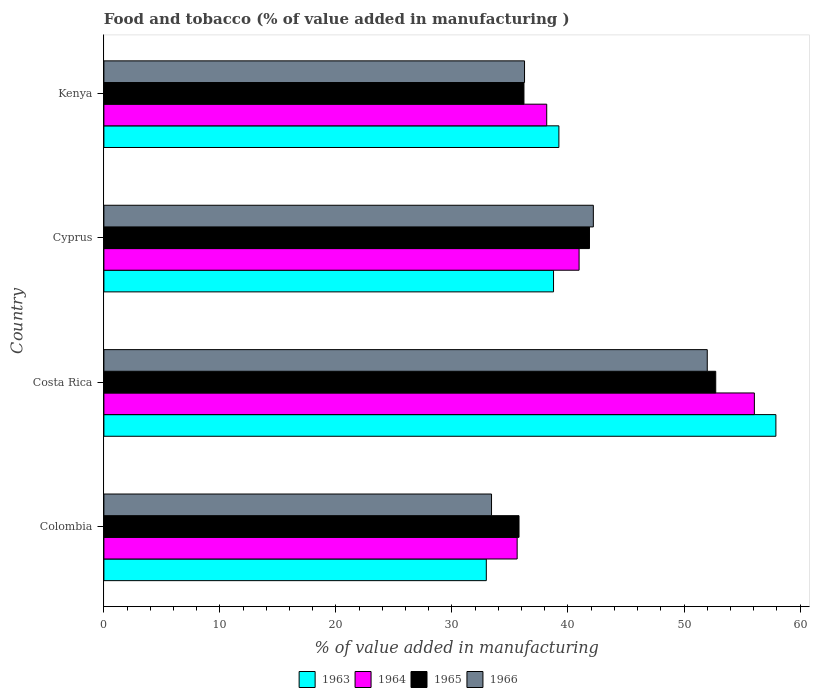How many groups of bars are there?
Your answer should be compact. 4. Are the number of bars per tick equal to the number of legend labels?
Ensure brevity in your answer.  Yes. How many bars are there on the 3rd tick from the top?
Offer a very short reply. 4. How many bars are there on the 3rd tick from the bottom?
Your response must be concise. 4. What is the label of the 4th group of bars from the top?
Your answer should be compact. Colombia. In how many cases, is the number of bars for a given country not equal to the number of legend labels?
Provide a succinct answer. 0. What is the value added in manufacturing food and tobacco in 1964 in Costa Rica?
Provide a short and direct response. 56.07. Across all countries, what is the maximum value added in manufacturing food and tobacco in 1966?
Offer a very short reply. 52. Across all countries, what is the minimum value added in manufacturing food and tobacco in 1966?
Ensure brevity in your answer.  33.41. What is the total value added in manufacturing food and tobacco in 1964 in the graph?
Offer a terse response. 170.81. What is the difference between the value added in manufacturing food and tobacco in 1966 in Costa Rica and that in Kenya?
Make the answer very short. 15.75. What is the difference between the value added in manufacturing food and tobacco in 1963 in Cyprus and the value added in manufacturing food and tobacco in 1964 in Costa Rica?
Offer a very short reply. -17.31. What is the average value added in manufacturing food and tobacco in 1965 per country?
Your answer should be compact. 41.64. What is the difference between the value added in manufacturing food and tobacco in 1965 and value added in manufacturing food and tobacco in 1963 in Cyprus?
Your answer should be very brief. 3.1. What is the ratio of the value added in manufacturing food and tobacco in 1966 in Colombia to that in Costa Rica?
Give a very brief answer. 0.64. Is the difference between the value added in manufacturing food and tobacco in 1965 in Costa Rica and Kenya greater than the difference between the value added in manufacturing food and tobacco in 1963 in Costa Rica and Kenya?
Make the answer very short. No. What is the difference between the highest and the second highest value added in manufacturing food and tobacco in 1965?
Keep it short and to the point. 10.88. What is the difference between the highest and the lowest value added in manufacturing food and tobacco in 1966?
Make the answer very short. 18.59. Is it the case that in every country, the sum of the value added in manufacturing food and tobacco in 1966 and value added in manufacturing food and tobacco in 1963 is greater than the sum of value added in manufacturing food and tobacco in 1965 and value added in manufacturing food and tobacco in 1964?
Your response must be concise. No. What does the 3rd bar from the top in Costa Rica represents?
Give a very brief answer. 1964. What does the 2nd bar from the bottom in Colombia represents?
Your response must be concise. 1964. Is it the case that in every country, the sum of the value added in manufacturing food and tobacco in 1966 and value added in manufacturing food and tobacco in 1965 is greater than the value added in manufacturing food and tobacco in 1964?
Provide a succinct answer. Yes. Are the values on the major ticks of X-axis written in scientific E-notation?
Provide a succinct answer. No. Does the graph contain any zero values?
Your answer should be very brief. No. Where does the legend appear in the graph?
Your answer should be very brief. Bottom center. How many legend labels are there?
Provide a short and direct response. 4. What is the title of the graph?
Offer a very short reply. Food and tobacco (% of value added in manufacturing ). Does "1963" appear as one of the legend labels in the graph?
Your answer should be compact. Yes. What is the label or title of the X-axis?
Provide a succinct answer. % of value added in manufacturing. What is the % of value added in manufacturing of 1963 in Colombia?
Provide a succinct answer. 32.96. What is the % of value added in manufacturing of 1964 in Colombia?
Make the answer very short. 35.62. What is the % of value added in manufacturing of 1965 in Colombia?
Provide a short and direct response. 35.78. What is the % of value added in manufacturing in 1966 in Colombia?
Offer a very short reply. 33.41. What is the % of value added in manufacturing of 1963 in Costa Rica?
Your response must be concise. 57.92. What is the % of value added in manufacturing in 1964 in Costa Rica?
Your answer should be very brief. 56.07. What is the % of value added in manufacturing of 1965 in Costa Rica?
Your answer should be very brief. 52.73. What is the % of value added in manufacturing of 1966 in Costa Rica?
Give a very brief answer. 52. What is the % of value added in manufacturing of 1963 in Cyprus?
Offer a terse response. 38.75. What is the % of value added in manufacturing in 1964 in Cyprus?
Keep it short and to the point. 40.96. What is the % of value added in manufacturing of 1965 in Cyprus?
Your response must be concise. 41.85. What is the % of value added in manufacturing in 1966 in Cyprus?
Ensure brevity in your answer.  42.19. What is the % of value added in manufacturing of 1963 in Kenya?
Ensure brevity in your answer.  39.22. What is the % of value added in manufacturing in 1964 in Kenya?
Offer a very short reply. 38.17. What is the % of value added in manufacturing of 1965 in Kenya?
Offer a terse response. 36.2. What is the % of value added in manufacturing of 1966 in Kenya?
Your answer should be compact. 36.25. Across all countries, what is the maximum % of value added in manufacturing in 1963?
Ensure brevity in your answer.  57.92. Across all countries, what is the maximum % of value added in manufacturing of 1964?
Give a very brief answer. 56.07. Across all countries, what is the maximum % of value added in manufacturing of 1965?
Ensure brevity in your answer.  52.73. Across all countries, what is the maximum % of value added in manufacturing of 1966?
Provide a short and direct response. 52. Across all countries, what is the minimum % of value added in manufacturing of 1963?
Provide a succinct answer. 32.96. Across all countries, what is the minimum % of value added in manufacturing of 1964?
Give a very brief answer. 35.62. Across all countries, what is the minimum % of value added in manufacturing in 1965?
Provide a short and direct response. 35.78. Across all countries, what is the minimum % of value added in manufacturing in 1966?
Your answer should be very brief. 33.41. What is the total % of value added in manufacturing in 1963 in the graph?
Your response must be concise. 168.85. What is the total % of value added in manufacturing in 1964 in the graph?
Ensure brevity in your answer.  170.81. What is the total % of value added in manufacturing of 1965 in the graph?
Your answer should be very brief. 166.57. What is the total % of value added in manufacturing in 1966 in the graph?
Your answer should be very brief. 163.86. What is the difference between the % of value added in manufacturing of 1963 in Colombia and that in Costa Rica?
Offer a very short reply. -24.96. What is the difference between the % of value added in manufacturing in 1964 in Colombia and that in Costa Rica?
Offer a very short reply. -20.45. What is the difference between the % of value added in manufacturing of 1965 in Colombia and that in Costa Rica?
Your answer should be compact. -16.95. What is the difference between the % of value added in manufacturing of 1966 in Colombia and that in Costa Rica?
Your response must be concise. -18.59. What is the difference between the % of value added in manufacturing of 1963 in Colombia and that in Cyprus?
Keep it short and to the point. -5.79. What is the difference between the % of value added in manufacturing in 1964 in Colombia and that in Cyprus?
Provide a succinct answer. -5.34. What is the difference between the % of value added in manufacturing of 1965 in Colombia and that in Cyprus?
Your response must be concise. -6.07. What is the difference between the % of value added in manufacturing in 1966 in Colombia and that in Cyprus?
Your answer should be very brief. -8.78. What is the difference between the % of value added in manufacturing in 1963 in Colombia and that in Kenya?
Keep it short and to the point. -6.26. What is the difference between the % of value added in manufacturing of 1964 in Colombia and that in Kenya?
Provide a succinct answer. -2.55. What is the difference between the % of value added in manufacturing in 1965 in Colombia and that in Kenya?
Your response must be concise. -0.42. What is the difference between the % of value added in manufacturing in 1966 in Colombia and that in Kenya?
Offer a very short reply. -2.84. What is the difference between the % of value added in manufacturing of 1963 in Costa Rica and that in Cyprus?
Offer a terse response. 19.17. What is the difference between the % of value added in manufacturing in 1964 in Costa Rica and that in Cyprus?
Offer a very short reply. 15.11. What is the difference between the % of value added in manufacturing of 1965 in Costa Rica and that in Cyprus?
Offer a terse response. 10.88. What is the difference between the % of value added in manufacturing in 1966 in Costa Rica and that in Cyprus?
Make the answer very short. 9.82. What is the difference between the % of value added in manufacturing in 1963 in Costa Rica and that in Kenya?
Your answer should be very brief. 18.7. What is the difference between the % of value added in manufacturing of 1964 in Costa Rica and that in Kenya?
Offer a terse response. 17.9. What is the difference between the % of value added in manufacturing in 1965 in Costa Rica and that in Kenya?
Offer a terse response. 16.53. What is the difference between the % of value added in manufacturing in 1966 in Costa Rica and that in Kenya?
Your answer should be compact. 15.75. What is the difference between the % of value added in manufacturing of 1963 in Cyprus and that in Kenya?
Your response must be concise. -0.46. What is the difference between the % of value added in manufacturing in 1964 in Cyprus and that in Kenya?
Offer a terse response. 2.79. What is the difference between the % of value added in manufacturing of 1965 in Cyprus and that in Kenya?
Provide a short and direct response. 5.65. What is the difference between the % of value added in manufacturing of 1966 in Cyprus and that in Kenya?
Make the answer very short. 5.93. What is the difference between the % of value added in manufacturing in 1963 in Colombia and the % of value added in manufacturing in 1964 in Costa Rica?
Your answer should be very brief. -23.11. What is the difference between the % of value added in manufacturing in 1963 in Colombia and the % of value added in manufacturing in 1965 in Costa Rica?
Your response must be concise. -19.77. What is the difference between the % of value added in manufacturing of 1963 in Colombia and the % of value added in manufacturing of 1966 in Costa Rica?
Your answer should be very brief. -19.04. What is the difference between the % of value added in manufacturing of 1964 in Colombia and the % of value added in manufacturing of 1965 in Costa Rica?
Ensure brevity in your answer.  -17.11. What is the difference between the % of value added in manufacturing in 1964 in Colombia and the % of value added in manufacturing in 1966 in Costa Rica?
Your answer should be compact. -16.38. What is the difference between the % of value added in manufacturing in 1965 in Colombia and the % of value added in manufacturing in 1966 in Costa Rica?
Ensure brevity in your answer.  -16.22. What is the difference between the % of value added in manufacturing of 1963 in Colombia and the % of value added in manufacturing of 1964 in Cyprus?
Your answer should be very brief. -8. What is the difference between the % of value added in manufacturing in 1963 in Colombia and the % of value added in manufacturing in 1965 in Cyprus?
Offer a very short reply. -8.89. What is the difference between the % of value added in manufacturing of 1963 in Colombia and the % of value added in manufacturing of 1966 in Cyprus?
Your answer should be compact. -9.23. What is the difference between the % of value added in manufacturing of 1964 in Colombia and the % of value added in manufacturing of 1965 in Cyprus?
Your response must be concise. -6.23. What is the difference between the % of value added in manufacturing in 1964 in Colombia and the % of value added in manufacturing in 1966 in Cyprus?
Your response must be concise. -6.57. What is the difference between the % of value added in manufacturing of 1965 in Colombia and the % of value added in manufacturing of 1966 in Cyprus?
Provide a short and direct response. -6.41. What is the difference between the % of value added in manufacturing of 1963 in Colombia and the % of value added in manufacturing of 1964 in Kenya?
Keep it short and to the point. -5.21. What is the difference between the % of value added in manufacturing in 1963 in Colombia and the % of value added in manufacturing in 1965 in Kenya?
Keep it short and to the point. -3.24. What is the difference between the % of value added in manufacturing in 1963 in Colombia and the % of value added in manufacturing in 1966 in Kenya?
Give a very brief answer. -3.29. What is the difference between the % of value added in manufacturing of 1964 in Colombia and the % of value added in manufacturing of 1965 in Kenya?
Give a very brief answer. -0.58. What is the difference between the % of value added in manufacturing in 1964 in Colombia and the % of value added in manufacturing in 1966 in Kenya?
Make the answer very short. -0.63. What is the difference between the % of value added in manufacturing of 1965 in Colombia and the % of value added in manufacturing of 1966 in Kenya?
Provide a short and direct response. -0.47. What is the difference between the % of value added in manufacturing in 1963 in Costa Rica and the % of value added in manufacturing in 1964 in Cyprus?
Offer a very short reply. 16.96. What is the difference between the % of value added in manufacturing of 1963 in Costa Rica and the % of value added in manufacturing of 1965 in Cyprus?
Give a very brief answer. 16.07. What is the difference between the % of value added in manufacturing in 1963 in Costa Rica and the % of value added in manufacturing in 1966 in Cyprus?
Ensure brevity in your answer.  15.73. What is the difference between the % of value added in manufacturing in 1964 in Costa Rica and the % of value added in manufacturing in 1965 in Cyprus?
Give a very brief answer. 14.21. What is the difference between the % of value added in manufacturing of 1964 in Costa Rica and the % of value added in manufacturing of 1966 in Cyprus?
Your answer should be compact. 13.88. What is the difference between the % of value added in manufacturing of 1965 in Costa Rica and the % of value added in manufacturing of 1966 in Cyprus?
Provide a short and direct response. 10.55. What is the difference between the % of value added in manufacturing of 1963 in Costa Rica and the % of value added in manufacturing of 1964 in Kenya?
Offer a very short reply. 19.75. What is the difference between the % of value added in manufacturing of 1963 in Costa Rica and the % of value added in manufacturing of 1965 in Kenya?
Provide a succinct answer. 21.72. What is the difference between the % of value added in manufacturing in 1963 in Costa Rica and the % of value added in manufacturing in 1966 in Kenya?
Offer a very short reply. 21.67. What is the difference between the % of value added in manufacturing of 1964 in Costa Rica and the % of value added in manufacturing of 1965 in Kenya?
Make the answer very short. 19.86. What is the difference between the % of value added in manufacturing of 1964 in Costa Rica and the % of value added in manufacturing of 1966 in Kenya?
Keep it short and to the point. 19.81. What is the difference between the % of value added in manufacturing in 1965 in Costa Rica and the % of value added in manufacturing in 1966 in Kenya?
Keep it short and to the point. 16.48. What is the difference between the % of value added in manufacturing in 1963 in Cyprus and the % of value added in manufacturing in 1964 in Kenya?
Ensure brevity in your answer.  0.59. What is the difference between the % of value added in manufacturing of 1963 in Cyprus and the % of value added in manufacturing of 1965 in Kenya?
Your answer should be compact. 2.55. What is the difference between the % of value added in manufacturing in 1963 in Cyprus and the % of value added in manufacturing in 1966 in Kenya?
Offer a terse response. 2.5. What is the difference between the % of value added in manufacturing of 1964 in Cyprus and the % of value added in manufacturing of 1965 in Kenya?
Keep it short and to the point. 4.75. What is the difference between the % of value added in manufacturing in 1964 in Cyprus and the % of value added in manufacturing in 1966 in Kenya?
Your answer should be very brief. 4.7. What is the difference between the % of value added in manufacturing of 1965 in Cyprus and the % of value added in manufacturing of 1966 in Kenya?
Provide a succinct answer. 5.6. What is the average % of value added in manufacturing of 1963 per country?
Your answer should be very brief. 42.21. What is the average % of value added in manufacturing of 1964 per country?
Ensure brevity in your answer.  42.7. What is the average % of value added in manufacturing of 1965 per country?
Ensure brevity in your answer.  41.64. What is the average % of value added in manufacturing of 1966 per country?
Provide a succinct answer. 40.96. What is the difference between the % of value added in manufacturing of 1963 and % of value added in manufacturing of 1964 in Colombia?
Ensure brevity in your answer.  -2.66. What is the difference between the % of value added in manufacturing of 1963 and % of value added in manufacturing of 1965 in Colombia?
Keep it short and to the point. -2.82. What is the difference between the % of value added in manufacturing in 1963 and % of value added in manufacturing in 1966 in Colombia?
Offer a terse response. -0.45. What is the difference between the % of value added in manufacturing in 1964 and % of value added in manufacturing in 1965 in Colombia?
Your answer should be very brief. -0.16. What is the difference between the % of value added in manufacturing in 1964 and % of value added in manufacturing in 1966 in Colombia?
Offer a terse response. 2.21. What is the difference between the % of value added in manufacturing in 1965 and % of value added in manufacturing in 1966 in Colombia?
Your response must be concise. 2.37. What is the difference between the % of value added in manufacturing in 1963 and % of value added in manufacturing in 1964 in Costa Rica?
Offer a terse response. 1.85. What is the difference between the % of value added in manufacturing in 1963 and % of value added in manufacturing in 1965 in Costa Rica?
Your response must be concise. 5.19. What is the difference between the % of value added in manufacturing in 1963 and % of value added in manufacturing in 1966 in Costa Rica?
Keep it short and to the point. 5.92. What is the difference between the % of value added in manufacturing in 1964 and % of value added in manufacturing in 1965 in Costa Rica?
Your answer should be compact. 3.33. What is the difference between the % of value added in manufacturing in 1964 and % of value added in manufacturing in 1966 in Costa Rica?
Give a very brief answer. 4.06. What is the difference between the % of value added in manufacturing of 1965 and % of value added in manufacturing of 1966 in Costa Rica?
Give a very brief answer. 0.73. What is the difference between the % of value added in manufacturing in 1963 and % of value added in manufacturing in 1964 in Cyprus?
Keep it short and to the point. -2.2. What is the difference between the % of value added in manufacturing in 1963 and % of value added in manufacturing in 1965 in Cyprus?
Your answer should be compact. -3.1. What is the difference between the % of value added in manufacturing in 1963 and % of value added in manufacturing in 1966 in Cyprus?
Provide a succinct answer. -3.43. What is the difference between the % of value added in manufacturing in 1964 and % of value added in manufacturing in 1965 in Cyprus?
Keep it short and to the point. -0.9. What is the difference between the % of value added in manufacturing of 1964 and % of value added in manufacturing of 1966 in Cyprus?
Provide a short and direct response. -1.23. What is the difference between the % of value added in manufacturing in 1963 and % of value added in manufacturing in 1964 in Kenya?
Offer a very short reply. 1.05. What is the difference between the % of value added in manufacturing in 1963 and % of value added in manufacturing in 1965 in Kenya?
Ensure brevity in your answer.  3.01. What is the difference between the % of value added in manufacturing in 1963 and % of value added in manufacturing in 1966 in Kenya?
Your answer should be very brief. 2.96. What is the difference between the % of value added in manufacturing of 1964 and % of value added in manufacturing of 1965 in Kenya?
Provide a succinct answer. 1.96. What is the difference between the % of value added in manufacturing of 1964 and % of value added in manufacturing of 1966 in Kenya?
Keep it short and to the point. 1.91. What is the difference between the % of value added in manufacturing in 1965 and % of value added in manufacturing in 1966 in Kenya?
Offer a terse response. -0.05. What is the ratio of the % of value added in manufacturing of 1963 in Colombia to that in Costa Rica?
Keep it short and to the point. 0.57. What is the ratio of the % of value added in manufacturing in 1964 in Colombia to that in Costa Rica?
Keep it short and to the point. 0.64. What is the ratio of the % of value added in manufacturing in 1965 in Colombia to that in Costa Rica?
Provide a succinct answer. 0.68. What is the ratio of the % of value added in manufacturing of 1966 in Colombia to that in Costa Rica?
Make the answer very short. 0.64. What is the ratio of the % of value added in manufacturing of 1963 in Colombia to that in Cyprus?
Ensure brevity in your answer.  0.85. What is the ratio of the % of value added in manufacturing of 1964 in Colombia to that in Cyprus?
Offer a very short reply. 0.87. What is the ratio of the % of value added in manufacturing of 1965 in Colombia to that in Cyprus?
Provide a succinct answer. 0.85. What is the ratio of the % of value added in manufacturing of 1966 in Colombia to that in Cyprus?
Your response must be concise. 0.79. What is the ratio of the % of value added in manufacturing of 1963 in Colombia to that in Kenya?
Your answer should be very brief. 0.84. What is the ratio of the % of value added in manufacturing in 1964 in Colombia to that in Kenya?
Offer a terse response. 0.93. What is the ratio of the % of value added in manufacturing of 1965 in Colombia to that in Kenya?
Keep it short and to the point. 0.99. What is the ratio of the % of value added in manufacturing in 1966 in Colombia to that in Kenya?
Provide a short and direct response. 0.92. What is the ratio of the % of value added in manufacturing of 1963 in Costa Rica to that in Cyprus?
Your answer should be very brief. 1.49. What is the ratio of the % of value added in manufacturing of 1964 in Costa Rica to that in Cyprus?
Ensure brevity in your answer.  1.37. What is the ratio of the % of value added in manufacturing in 1965 in Costa Rica to that in Cyprus?
Provide a succinct answer. 1.26. What is the ratio of the % of value added in manufacturing in 1966 in Costa Rica to that in Cyprus?
Keep it short and to the point. 1.23. What is the ratio of the % of value added in manufacturing of 1963 in Costa Rica to that in Kenya?
Your response must be concise. 1.48. What is the ratio of the % of value added in manufacturing in 1964 in Costa Rica to that in Kenya?
Make the answer very short. 1.47. What is the ratio of the % of value added in manufacturing in 1965 in Costa Rica to that in Kenya?
Ensure brevity in your answer.  1.46. What is the ratio of the % of value added in manufacturing of 1966 in Costa Rica to that in Kenya?
Offer a terse response. 1.43. What is the ratio of the % of value added in manufacturing of 1963 in Cyprus to that in Kenya?
Offer a terse response. 0.99. What is the ratio of the % of value added in manufacturing of 1964 in Cyprus to that in Kenya?
Your answer should be compact. 1.07. What is the ratio of the % of value added in manufacturing in 1965 in Cyprus to that in Kenya?
Make the answer very short. 1.16. What is the ratio of the % of value added in manufacturing in 1966 in Cyprus to that in Kenya?
Your response must be concise. 1.16. What is the difference between the highest and the second highest % of value added in manufacturing of 1963?
Keep it short and to the point. 18.7. What is the difference between the highest and the second highest % of value added in manufacturing in 1964?
Offer a terse response. 15.11. What is the difference between the highest and the second highest % of value added in manufacturing in 1965?
Ensure brevity in your answer.  10.88. What is the difference between the highest and the second highest % of value added in manufacturing in 1966?
Ensure brevity in your answer.  9.82. What is the difference between the highest and the lowest % of value added in manufacturing of 1963?
Your answer should be very brief. 24.96. What is the difference between the highest and the lowest % of value added in manufacturing of 1964?
Give a very brief answer. 20.45. What is the difference between the highest and the lowest % of value added in manufacturing in 1965?
Your response must be concise. 16.95. What is the difference between the highest and the lowest % of value added in manufacturing in 1966?
Provide a short and direct response. 18.59. 